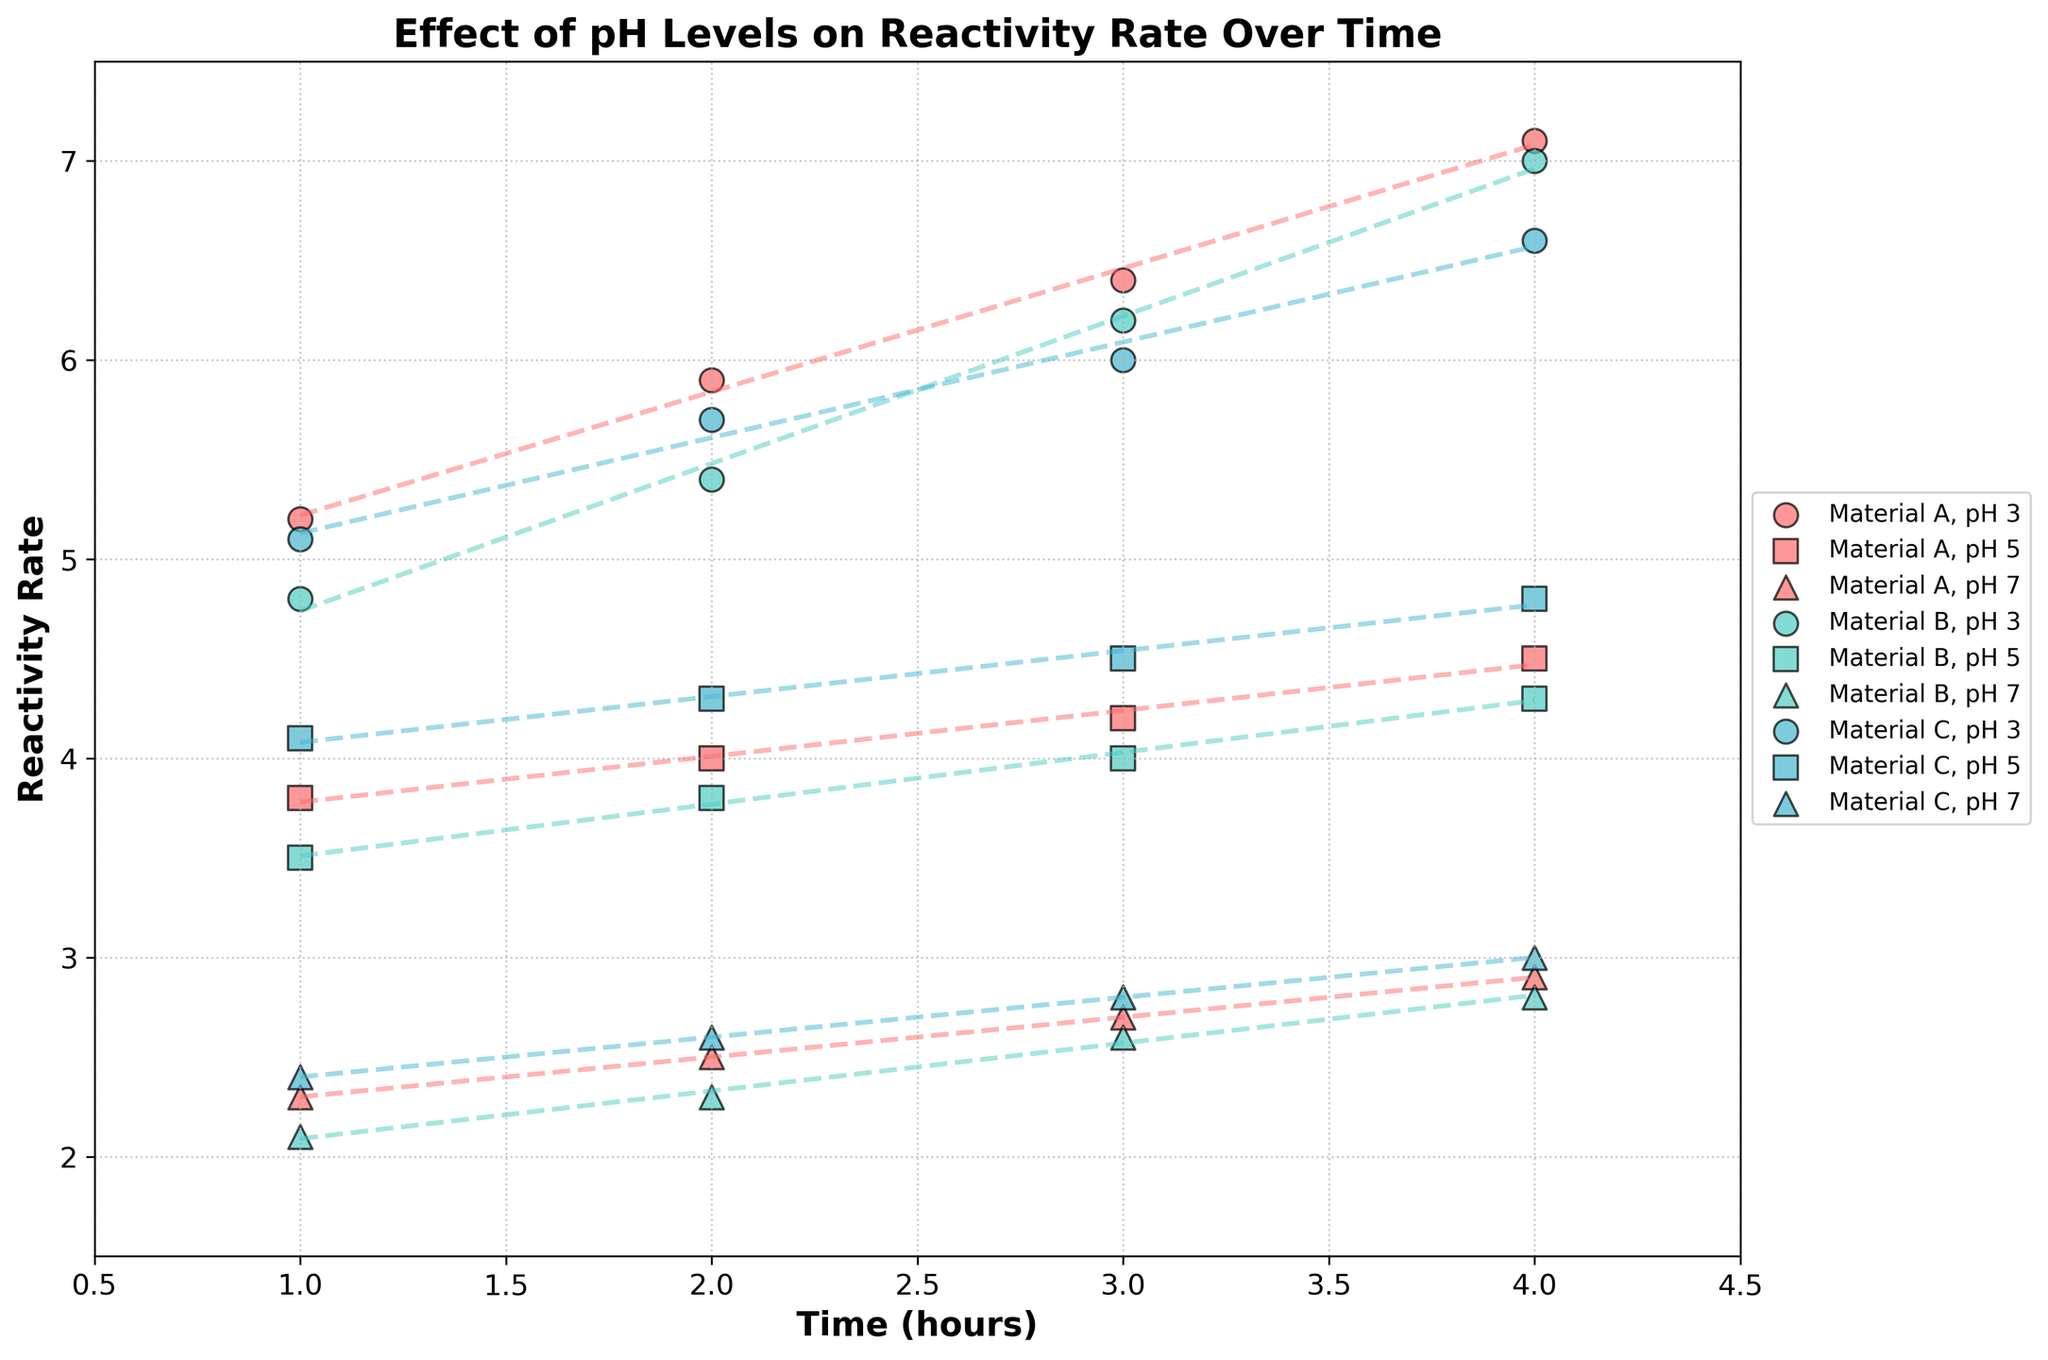What's the x-axis label? The x-axis label indicates the variable that is being measured along the horizontal axis. In this case, the x-axis label is "Time (hours)."
Answer: Time (hours) What color represents Material C in the plot? Each material is represented by a specific color in the plot. According to the code, Material C is represented by the color corresponding to '#45B7D1', which is blue.
Answer: Blue Which pH level shows the highest reactivity rate at 4 hours for Material A? At 4 hours, each pH level has a specific reactivity rate plotted. By looking at the trend lines and data points at the 4-hour mark, pH level 3 shows the highest reactivity rate for Material A.
Answer: pH 3 Comparing Material A and Material B at pH 7, which has a lower reactivity rate at 2 hours? To compare the reactivity rates of Material A and B at pH 7, look at the data points at the 2-hour mark — Material B has a reactivity rate of 2.3, which is lower than Material A's rate of 2.5.
Answer: Material B What is the general trend of reactivity rate for Material C at pH 5 over the given time? Observing the trend line for Material C at pH 5, we notice that the reactivity rate generally increases from 4.1 to 4.8 over 4 hours, indicating a consistent upward trend.
Answer: Increasing Which material shows the steepest increase in reactivity rate at pH 3? The steepness of the increase can be determined by the slope of the trend lines. By comparing slopes, Material B, which increases from 4.8 to 7.0 in 4 hours, shows the steepest increase in reactivity rate at pH 3.
Answer: Material B For Material A, how does the reactivity rate change from pH 3 to pH 7 at 3 hours? Comparing the reactivity rates at 3 hours for Material A: pH 3 has a reactivity rate of 6.4, pH 5 has 4.2, and pH 7 has 2.7. There is a decrease as the pH level increases.
Answer: Decreases Which Material shows the smallest range of reactivity rates at pH 7 over the time period? To find the smallest range, calculate the difference between the max and min reactivity rates at pH 7 for each material. Material B ranges from 2.1 to 2.8, which is the smallest range among the materials.
Answer: Material B What is the reactivity rate for Material C at pH 3 and 2 hours? Look at the data points for Material C at pH 3 and find the corresponding reactivity rate at 2 hours. It is 5.7.
Answer: 5.7 